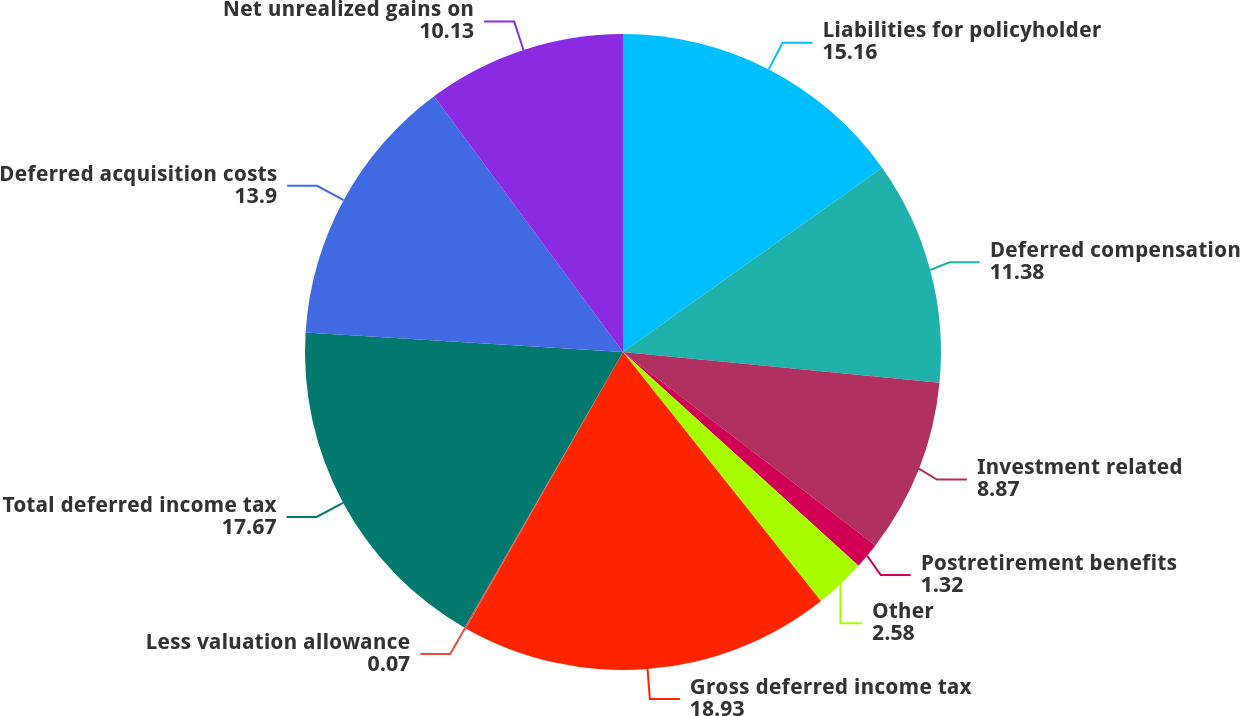<chart> <loc_0><loc_0><loc_500><loc_500><pie_chart><fcel>Liabilities for policyholder<fcel>Deferred compensation<fcel>Investment related<fcel>Postretirement benefits<fcel>Other<fcel>Gross deferred income tax<fcel>Less valuation allowance<fcel>Total deferred income tax<fcel>Deferred acquisition costs<fcel>Net unrealized gains on<nl><fcel>15.16%<fcel>11.38%<fcel>8.87%<fcel>1.32%<fcel>2.58%<fcel>18.93%<fcel>0.07%<fcel>17.67%<fcel>13.9%<fcel>10.13%<nl></chart> 